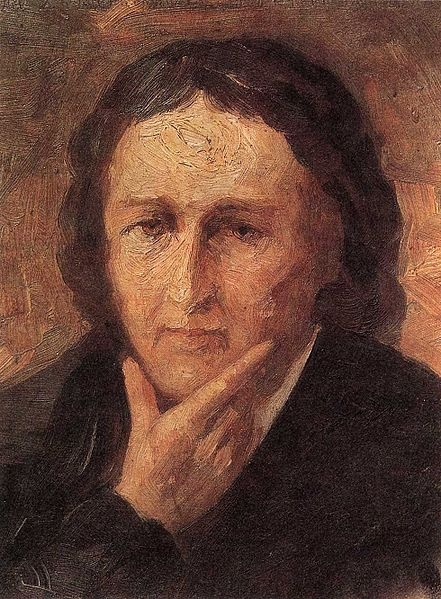How does the artist use color to express emotion in this image? The artist employs a palette of warm colors, using shades of orange, red and yellow in the background to create a stark contrast with the serene and melancholic mood of the person. This juxtaposition may signify the turmoil or passion underlying the quiet surface, or perhaps the vibrancy of life outside of the individual's introspective state. 